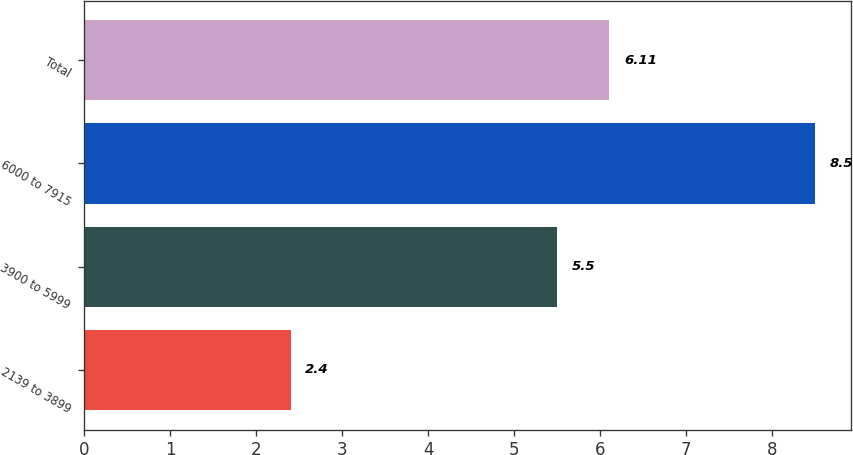Convert chart to OTSL. <chart><loc_0><loc_0><loc_500><loc_500><bar_chart><fcel>2139 to 3899<fcel>3900 to 5999<fcel>6000 to 7915<fcel>Total<nl><fcel>2.4<fcel>5.5<fcel>8.5<fcel>6.11<nl></chart> 